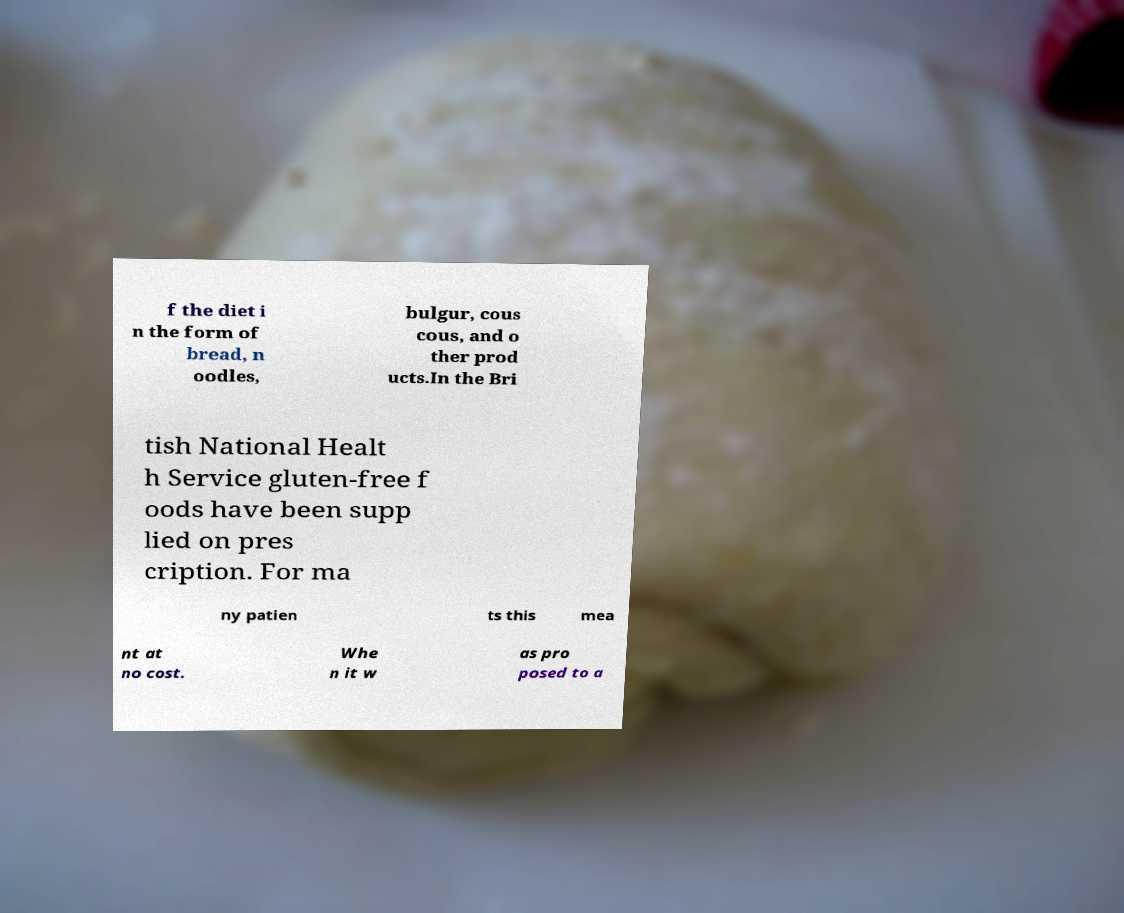There's text embedded in this image that I need extracted. Can you transcribe it verbatim? f the diet i n the form of bread, n oodles, bulgur, cous cous, and o ther prod ucts.In the Bri tish National Healt h Service gluten-free f oods have been supp lied on pres cription. For ma ny patien ts this mea nt at no cost. Whe n it w as pro posed to a 